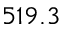Convert formula to latex. <formula><loc_0><loc_0><loc_500><loc_500>5 1 9 . 3</formula> 